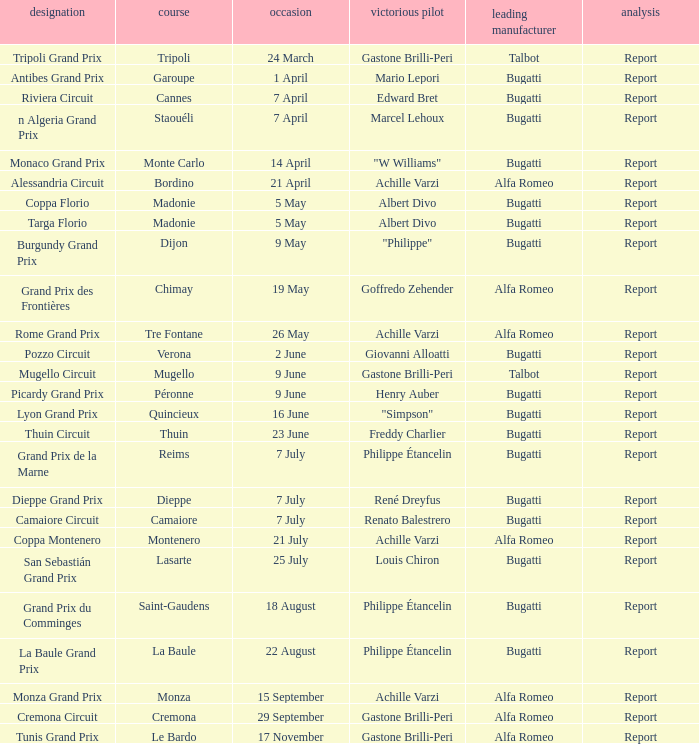What Winning driver has a Name of mugello circuit? Gastone Brilli-Peri. 